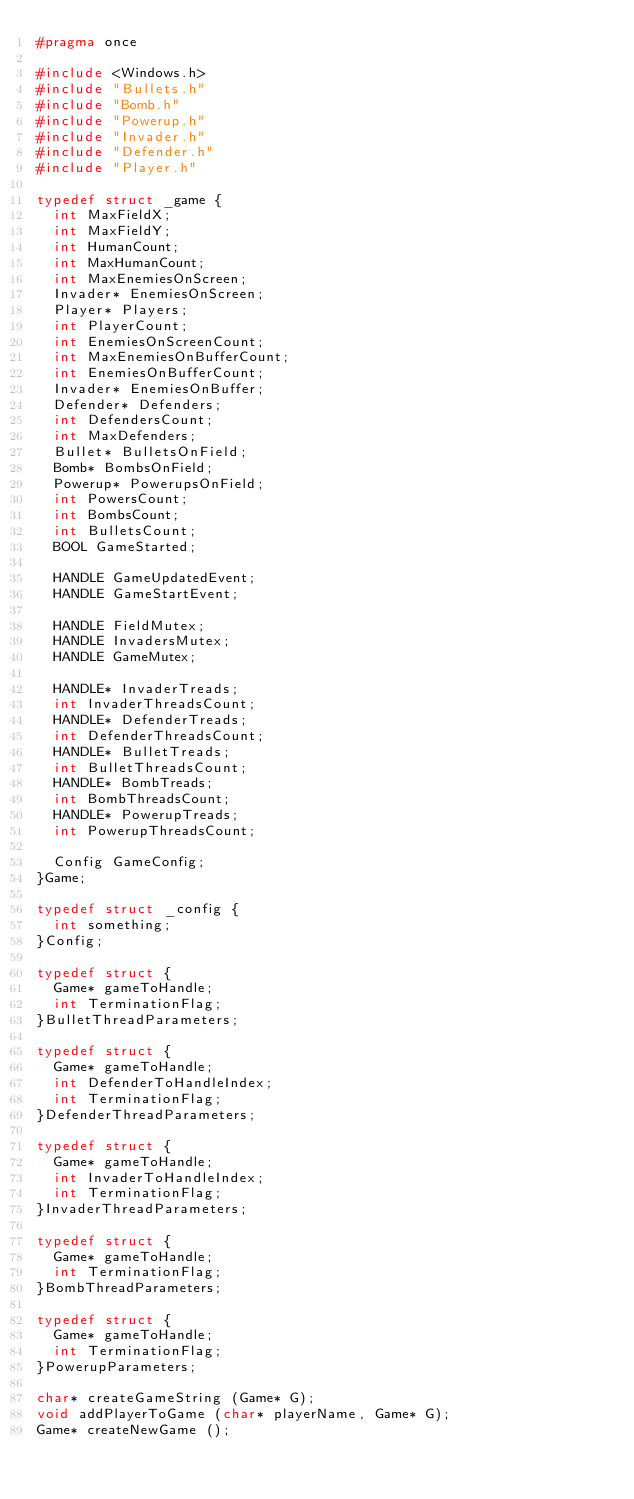<code> <loc_0><loc_0><loc_500><loc_500><_C_>#pragma once

#include <Windows.h>
#include "Bullets.h"
#include "Bomb.h"
#include "Powerup.h"
#include "Invader.h"
#include "Defender.h"
#include "Player.h"

typedef struct _game {
	int MaxFieldX;
	int MaxFieldY;
	int HumanCount;
	int MaxHumanCount;
	int MaxEnemiesOnScreen;
	Invader* EnemiesOnScreen;
	Player* Players;
	int PlayerCount;
	int EnemiesOnScreenCount;
	int MaxEnemiesOnBufferCount;
	int EnemiesOnBufferCount;
	Invader* EnemiesOnBuffer;
	Defender* Defenders;
	int DefendersCount;
	int MaxDefenders;
	Bullet* BulletsOnField;
	Bomb* BombsOnField;
	Powerup* PowerupsOnField;
	int PowersCount;
	int BombsCount;
	int BulletsCount;
	BOOL GameStarted;

	HANDLE GameUpdatedEvent;
	HANDLE GameStartEvent;
	
	HANDLE FieldMutex;
	HANDLE InvadersMutex;
	HANDLE GameMutex;

	HANDLE* InvaderTreads;
	int InvaderThreadsCount;
	HANDLE* DefenderTreads;
	int DefenderThreadsCount;
	HANDLE* BulletTreads;
	int BulletThreadsCount;
	HANDLE* BombTreads;
	int BombThreadsCount;
	HANDLE* PowerupTreads;
	int PowerupThreadsCount;

	Config GameConfig;
}Game;

typedef struct _config {
	int something;
}Config;

typedef struct {
	Game* gameToHandle;
	int TerminationFlag;
}BulletThreadParameters;

typedef struct {
	Game* gameToHandle;
	int DefenderToHandleIndex;
	int TerminationFlag;
}DefenderThreadParameters;

typedef struct {
	Game* gameToHandle;
	int InvaderToHandleIndex;
	int TerminationFlag;
}InvaderThreadParameters;

typedef struct {
	Game* gameToHandle;
	int TerminationFlag;
}BombThreadParameters;

typedef struct {
	Game* gameToHandle;
	int TerminationFlag;
}PowerupParameters;

char* createGameString (Game* G);
void addPlayerToGame (char* playerName, Game* G);
Game* createNewGame ();

</code> 